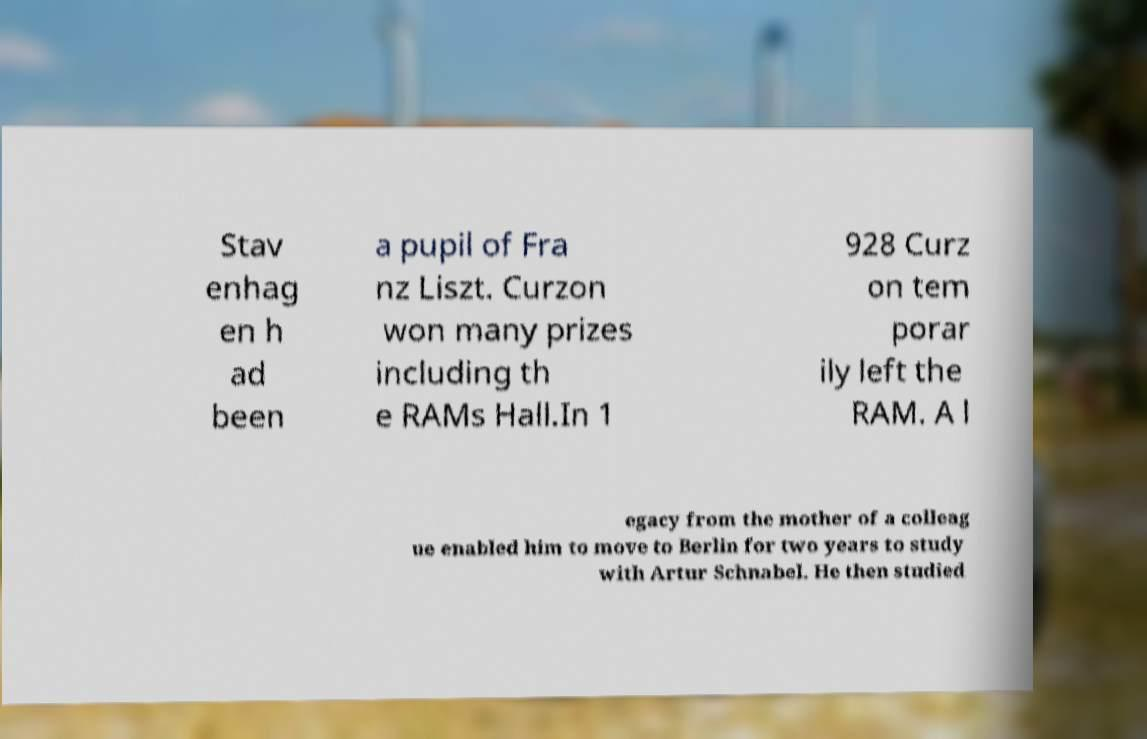Can you accurately transcribe the text from the provided image for me? Stav enhag en h ad been a pupil of Fra nz Liszt. Curzon won many prizes including th e RAMs Hall.In 1 928 Curz on tem porar ily left the RAM. A l egacy from the mother of a colleag ue enabled him to move to Berlin for two years to study with Artur Schnabel. He then studied 